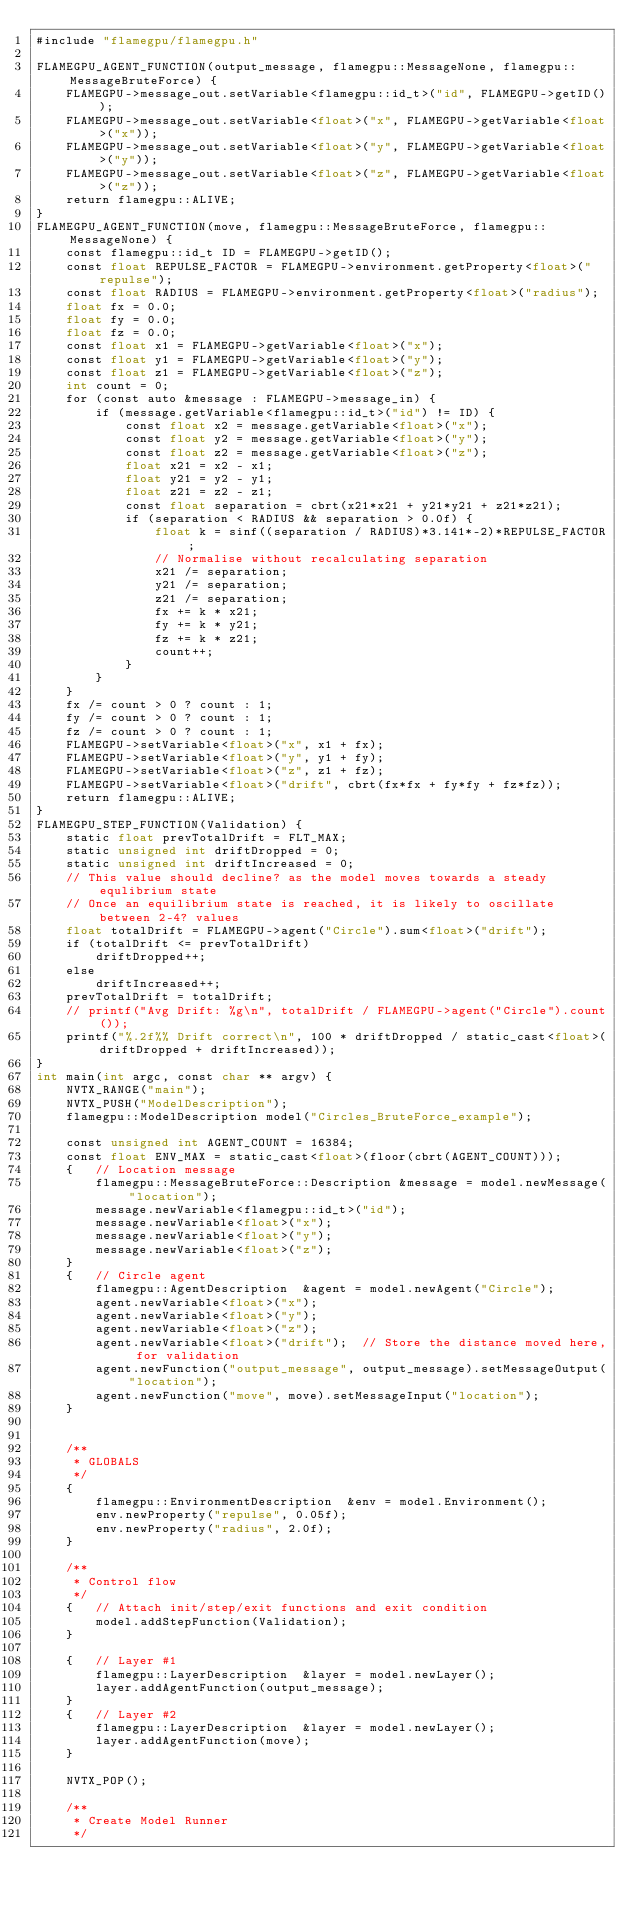Convert code to text. <code><loc_0><loc_0><loc_500><loc_500><_Cuda_>#include "flamegpu/flamegpu.h"

FLAMEGPU_AGENT_FUNCTION(output_message, flamegpu::MessageNone, flamegpu::MessageBruteForce) {
    FLAMEGPU->message_out.setVariable<flamegpu::id_t>("id", FLAMEGPU->getID());
    FLAMEGPU->message_out.setVariable<float>("x", FLAMEGPU->getVariable<float>("x"));
    FLAMEGPU->message_out.setVariable<float>("y", FLAMEGPU->getVariable<float>("y"));
    FLAMEGPU->message_out.setVariable<float>("z", FLAMEGPU->getVariable<float>("z"));
    return flamegpu::ALIVE;
}
FLAMEGPU_AGENT_FUNCTION(move, flamegpu::MessageBruteForce, flamegpu::MessageNone) {
    const flamegpu::id_t ID = FLAMEGPU->getID();
    const float REPULSE_FACTOR = FLAMEGPU->environment.getProperty<float>("repulse");
    const float RADIUS = FLAMEGPU->environment.getProperty<float>("radius");
    float fx = 0.0;
    float fy = 0.0;
    float fz = 0.0;
    const float x1 = FLAMEGPU->getVariable<float>("x");
    const float y1 = FLAMEGPU->getVariable<float>("y");
    const float z1 = FLAMEGPU->getVariable<float>("z");
    int count = 0;
    for (const auto &message : FLAMEGPU->message_in) {
        if (message.getVariable<flamegpu::id_t>("id") != ID) {
            const float x2 = message.getVariable<float>("x");
            const float y2 = message.getVariable<float>("y");
            const float z2 = message.getVariable<float>("z");
            float x21 = x2 - x1;
            float y21 = y2 - y1;
            float z21 = z2 - z1;
            const float separation = cbrt(x21*x21 + y21*y21 + z21*z21);
            if (separation < RADIUS && separation > 0.0f) {
                float k = sinf((separation / RADIUS)*3.141*-2)*REPULSE_FACTOR;
                // Normalise without recalculating separation
                x21 /= separation;
                y21 /= separation;
                z21 /= separation;
                fx += k * x21;
                fy += k * y21;
                fz += k * z21;
                count++;
            }
        }
    }
    fx /= count > 0 ? count : 1;
    fy /= count > 0 ? count : 1;
    fz /= count > 0 ? count : 1;
    FLAMEGPU->setVariable<float>("x", x1 + fx);
    FLAMEGPU->setVariable<float>("y", y1 + fy);
    FLAMEGPU->setVariable<float>("z", z1 + fz);
    FLAMEGPU->setVariable<float>("drift", cbrt(fx*fx + fy*fy + fz*fz));
    return flamegpu::ALIVE;
}
FLAMEGPU_STEP_FUNCTION(Validation) {
    static float prevTotalDrift = FLT_MAX;
    static unsigned int driftDropped = 0;
    static unsigned int driftIncreased = 0;
    // This value should decline? as the model moves towards a steady equlibrium state
    // Once an equilibrium state is reached, it is likely to oscillate between 2-4? values
    float totalDrift = FLAMEGPU->agent("Circle").sum<float>("drift");
    if (totalDrift <= prevTotalDrift)
        driftDropped++;
    else
        driftIncreased++;
    prevTotalDrift = totalDrift;
    // printf("Avg Drift: %g\n", totalDrift / FLAMEGPU->agent("Circle").count());
    printf("%.2f%% Drift correct\n", 100 * driftDropped / static_cast<float>(driftDropped + driftIncreased));
}
int main(int argc, const char ** argv) {
    NVTX_RANGE("main");
    NVTX_PUSH("ModelDescription");
    flamegpu::ModelDescription model("Circles_BruteForce_example");

    const unsigned int AGENT_COUNT = 16384;
    const float ENV_MAX = static_cast<float>(floor(cbrt(AGENT_COUNT)));
    {   // Location message
        flamegpu::MessageBruteForce::Description &message = model.newMessage("location");
        message.newVariable<flamegpu::id_t>("id");
        message.newVariable<float>("x");
        message.newVariable<float>("y");
        message.newVariable<float>("z");
    }
    {   // Circle agent
        flamegpu::AgentDescription  &agent = model.newAgent("Circle");
        agent.newVariable<float>("x");
        agent.newVariable<float>("y");
        agent.newVariable<float>("z");
        agent.newVariable<float>("drift");  // Store the distance moved here, for validation
        agent.newFunction("output_message", output_message).setMessageOutput("location");
        agent.newFunction("move", move).setMessageInput("location");
    }


    /**
     * GLOBALS
     */
    {
        flamegpu::EnvironmentDescription  &env = model.Environment();
        env.newProperty("repulse", 0.05f);
        env.newProperty("radius", 2.0f);
    }

    /**
     * Control flow
     */     
    {   // Attach init/step/exit functions and exit condition
        model.addStepFunction(Validation);
    }

    {   // Layer #1
        flamegpu::LayerDescription  &layer = model.newLayer();
        layer.addAgentFunction(output_message);
    }
    {   // Layer #2
        flamegpu::LayerDescription  &layer = model.newLayer();
        layer.addAgentFunction(move);
    }

    NVTX_POP();

    /**
     * Create Model Runner
     */</code> 